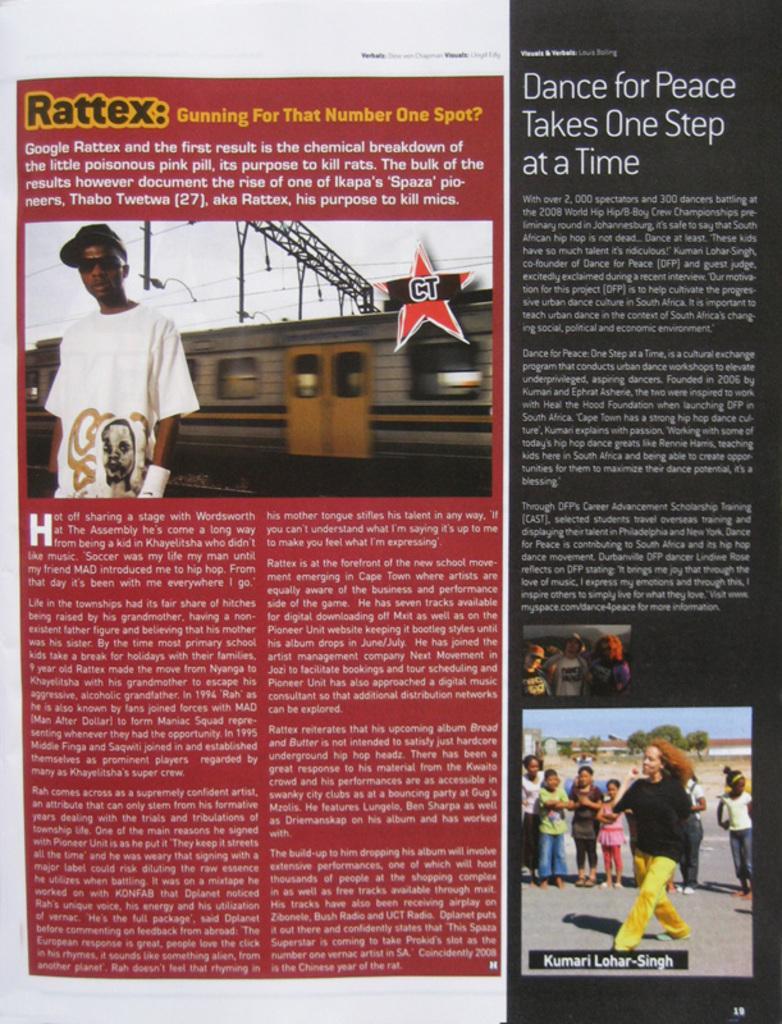Describe this image in one or two sentences. In this image there is a magazine article with text and pictures of person´s, train, metal rods, cables, trees and buildings. 